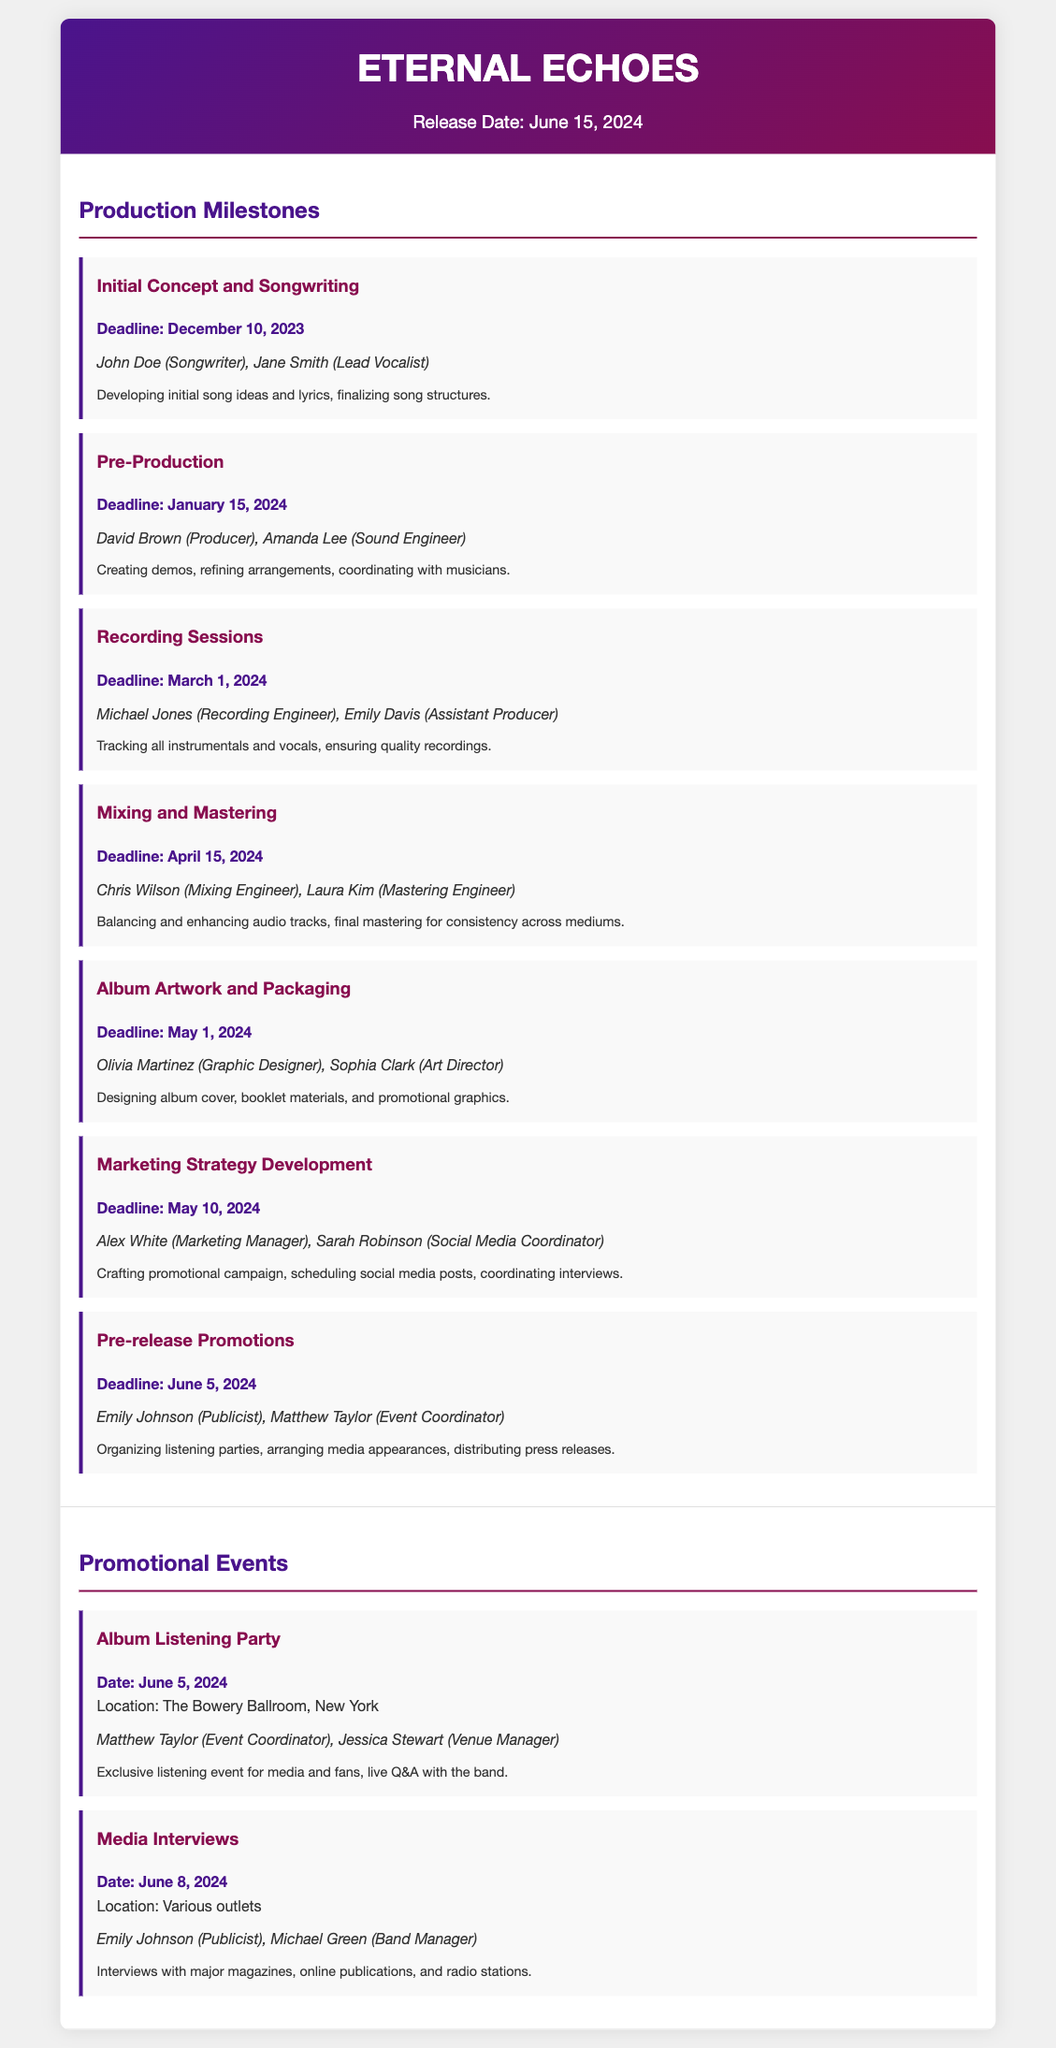what is the release date of the album? The release date is stated clearly in the header of the document.
Answer: June 15, 2024 who is responsible for initial concept and songwriting? This information is found under the "Production Milestones" section detailing responsibilities for each task.
Answer: John Doe, Jane Smith what is the deadline for mixing and mastering? The document specifies deadlines for each milestone under the "Production Milestones" section.
Answer: April 15, 2024 where is the album listening party taking place? The location of the album listening party is detailed in the "Promotional Events" section.
Answer: The Bowery Ballroom, New York who are the responsible parties for media interviews? This information can be found in the "Promotional Events" section, identifying the parties involved in that event.
Answer: Emily Johnson, Michael Green what is the deadline for pre-release promotions? The deadline is provided within the "Production Milestones" section of the document.
Answer: June 5, 2024 how many days are there between the start of recording sessions and the mixing and mastering deadline? This requires calculating the time between the two specified dates in the document, which are given in the "Production Milestones" section.
Answer: 45 days what is the purpose of the marketing strategy development milestone? This can be inferred from the details given under the milestone in the "Production Milestones" section.
Answer: Crafting promotional campaign which two roles are involved in album artwork and packaging? This information is contained within the "Production Milestones" section, specifying the responsible parties.
Answer: Olivia Martinez, Sophia Clark 